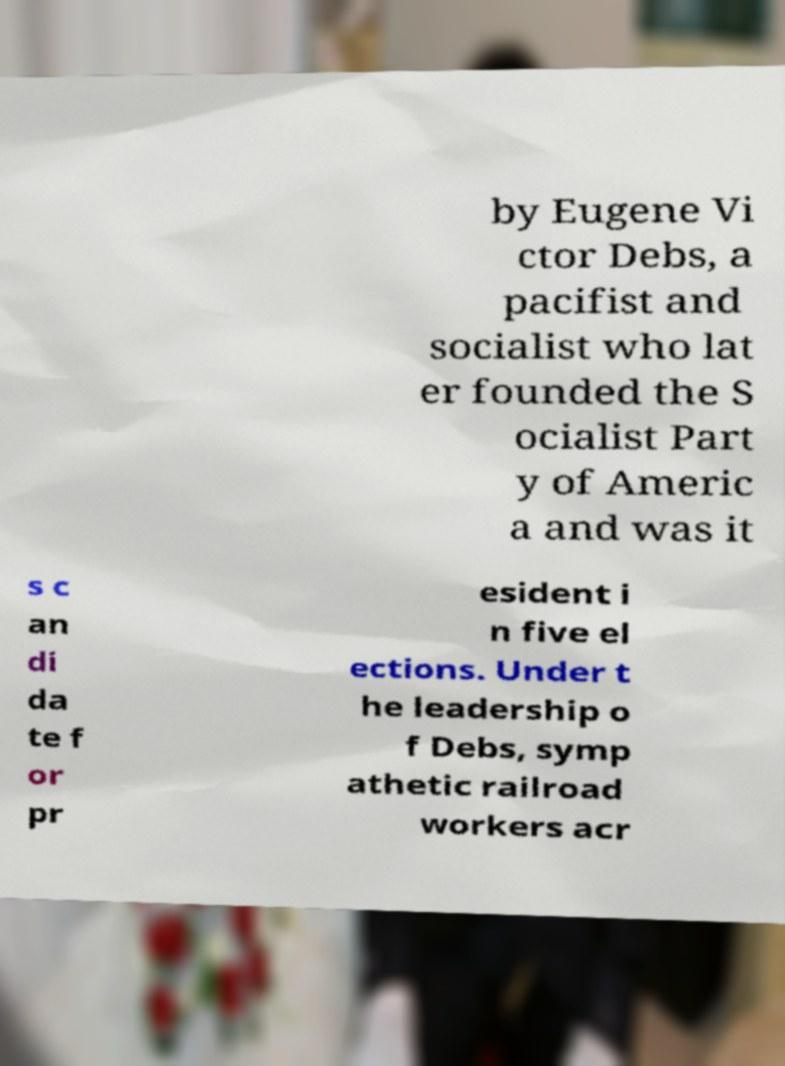Please identify and transcribe the text found in this image. by Eugene Vi ctor Debs, a pacifist and socialist who lat er founded the S ocialist Part y of Americ a and was it s c an di da te f or pr esident i n five el ections. Under t he leadership o f Debs, symp athetic railroad workers acr 